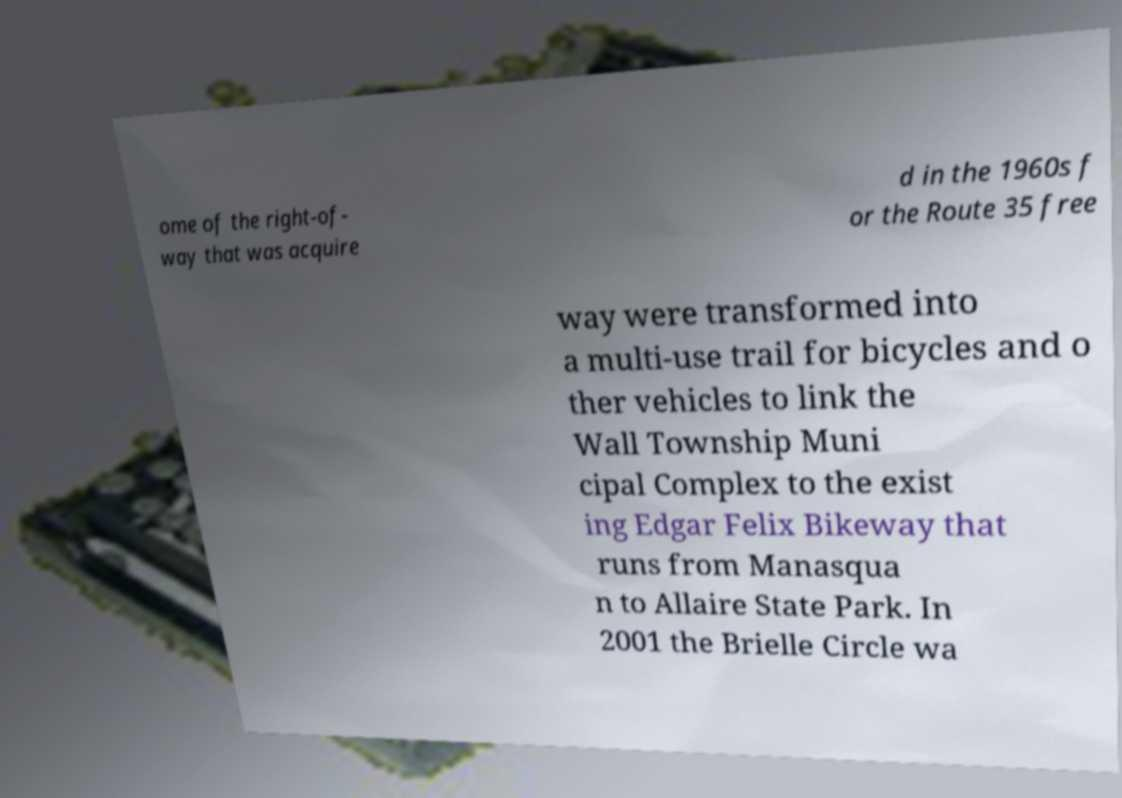Can you accurately transcribe the text from the provided image for me? ome of the right-of- way that was acquire d in the 1960s f or the Route 35 free way were transformed into a multi-use trail for bicycles and o ther vehicles to link the Wall Township Muni cipal Complex to the exist ing Edgar Felix Bikeway that runs from Manasqua n to Allaire State Park. In 2001 the Brielle Circle wa 